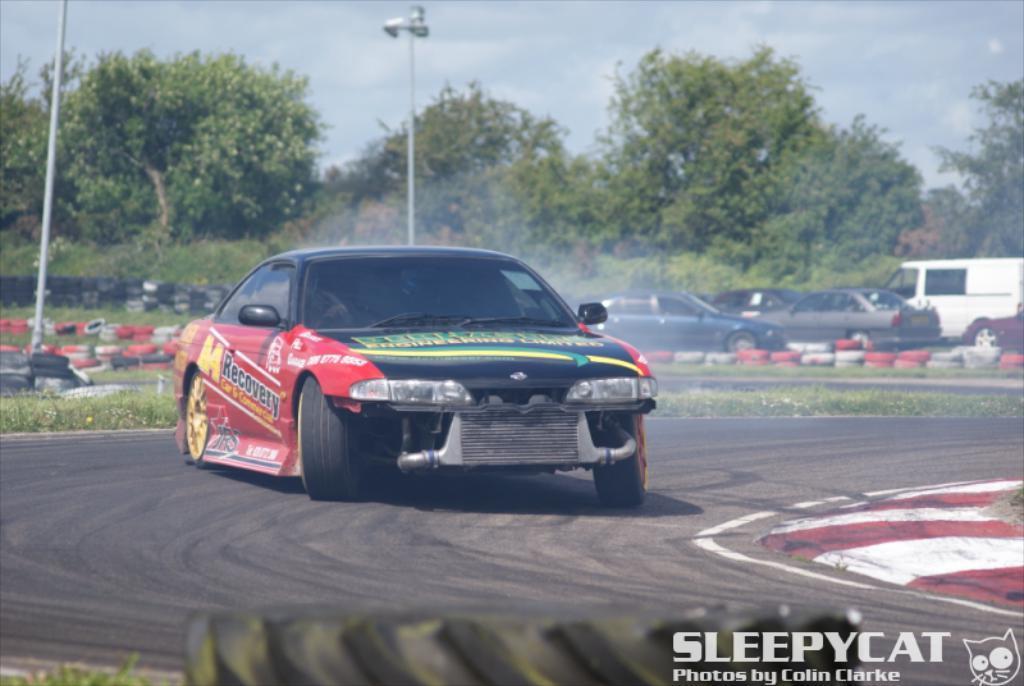Describe this image in one or two sentences. There is a sports car on the road in the foreground area of the image and text at the bottom side. There are vehicles, tires, trees, poles and the sky in the background. 